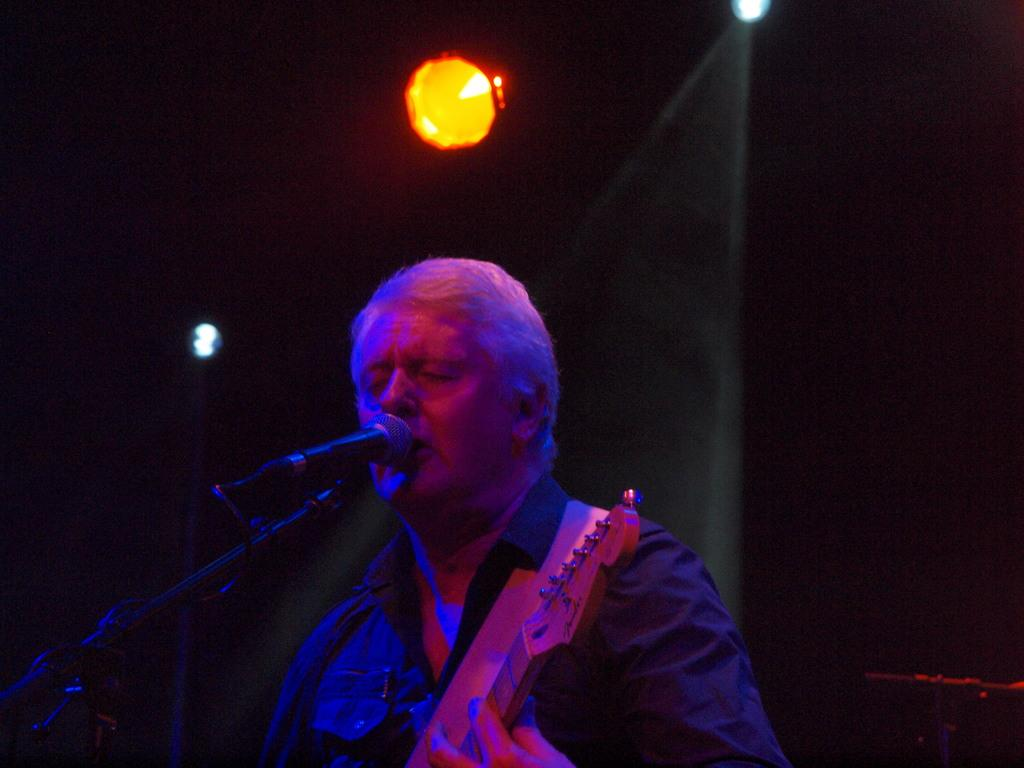What is the person in the image doing? The person is playing a guitar and singing a song. How is the person's voice being amplified in the image? The person is using a microphone. What can be seen at the top of the image? There are lights visible at the top of the image. What color is the sheet in the background of the image? The sheet in the background of the image is black. What type of worm can be seen crawling on the guitar in the image? There is no worm present in the image; the person is playing a guitar without any visible creatures. 